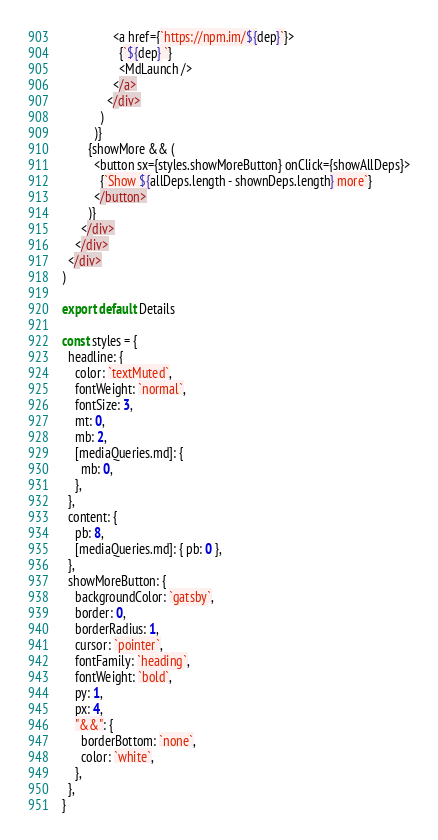Convert code to text. <code><loc_0><loc_0><loc_500><loc_500><_JavaScript_>                <a href={`https://npm.im/${dep}`}>
                  {`${dep} `}
                  <MdLaunch />
                </a>
              </div>
            )
          )}
        {showMore && (
          <button sx={styles.showMoreButton} onClick={showAllDeps}>
            {`Show ${allDeps.length - shownDeps.length} more`}
          </button>
        )}
      </div>
    </div>
  </div>
)

export default Details

const styles = {
  headline: {
    color: `textMuted`,
    fontWeight: `normal`,
    fontSize: 3,
    mt: 0,
    mb: 2,
    [mediaQueries.md]: {
      mb: 0,
    },
  },
  content: {
    pb: 8,
    [mediaQueries.md]: { pb: 0 },
  },
  showMoreButton: {
    backgroundColor: `gatsby`,
    border: 0,
    borderRadius: 1,
    cursor: `pointer`,
    fontFamily: `heading`,
    fontWeight: `bold`,
    py: 1,
    px: 4,
    "&&": {
      borderBottom: `none`,
      color: `white`,
    },
  },
}
</code> 